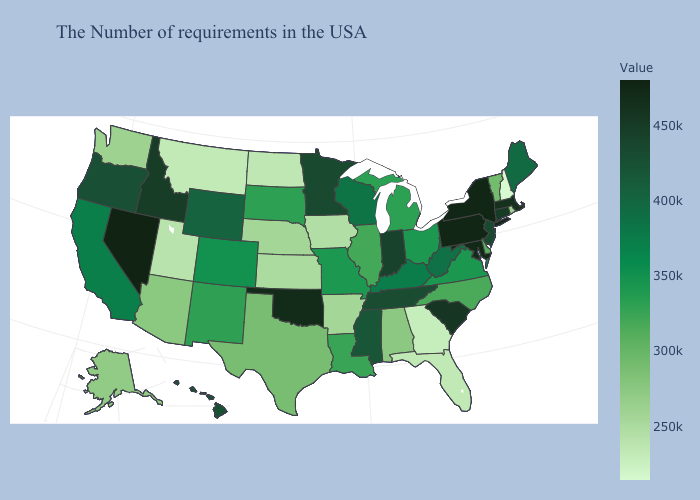Among the states that border Maine , which have the highest value?
Be succinct. New Hampshire. Does Ohio have the lowest value in the USA?
Be succinct. No. Is the legend a continuous bar?
Answer briefly. Yes. Which states have the lowest value in the Northeast?
Keep it brief. New Hampshire. Among the states that border Michigan , which have the lowest value?
Give a very brief answer. Ohio. Does the map have missing data?
Write a very short answer. No. 